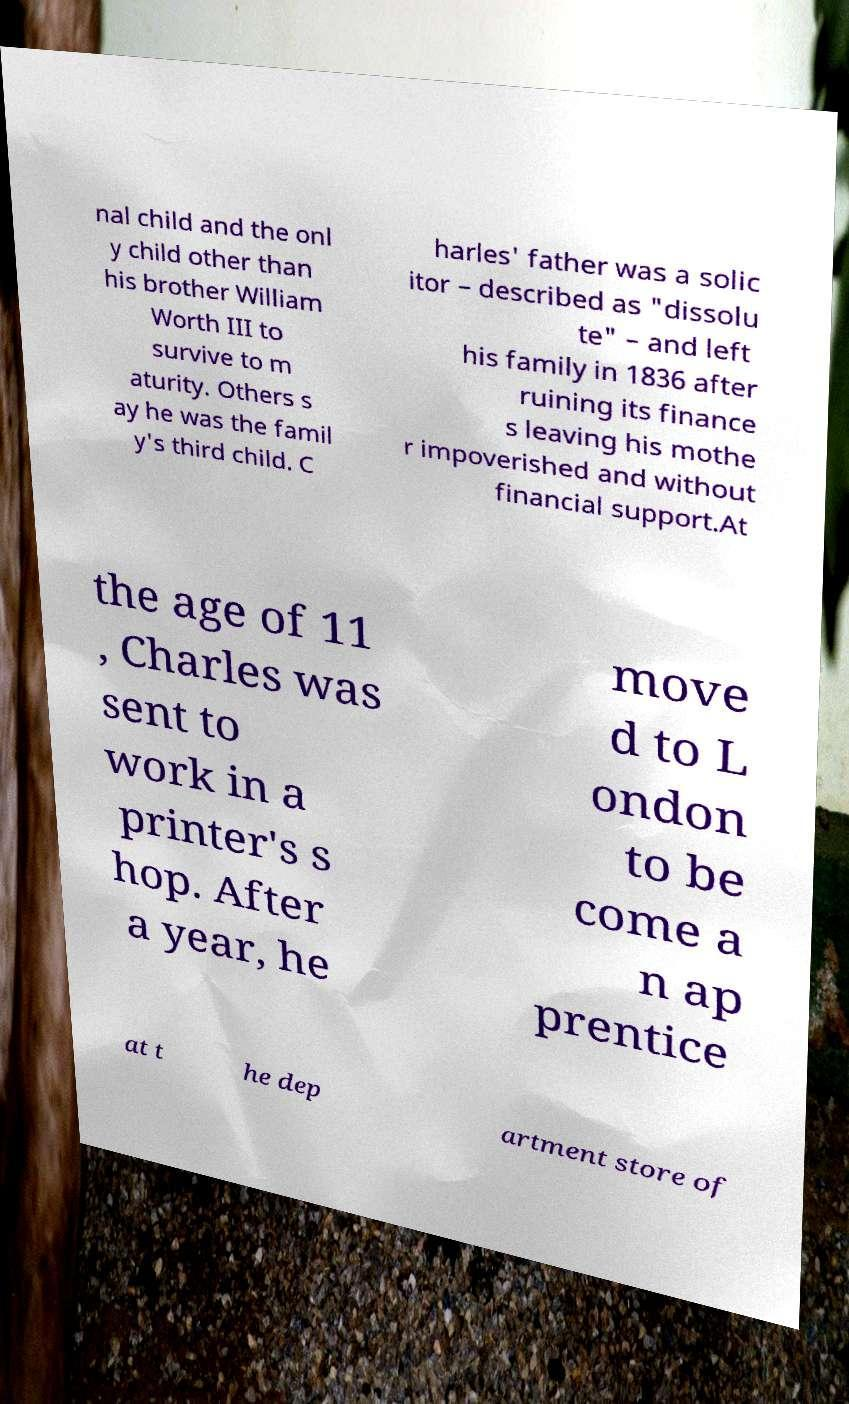Please read and relay the text visible in this image. What does it say? nal child and the onl y child other than his brother William Worth III to survive to m aturity. Others s ay he was the famil y's third child. C harles' father was a solic itor – described as "dissolu te" – and left his family in 1836 after ruining its finance s leaving his mothe r impoverished and without financial support.At the age of 11 , Charles was sent to work in a printer's s hop. After a year, he move d to L ondon to be come a n ap prentice at t he dep artment store of 